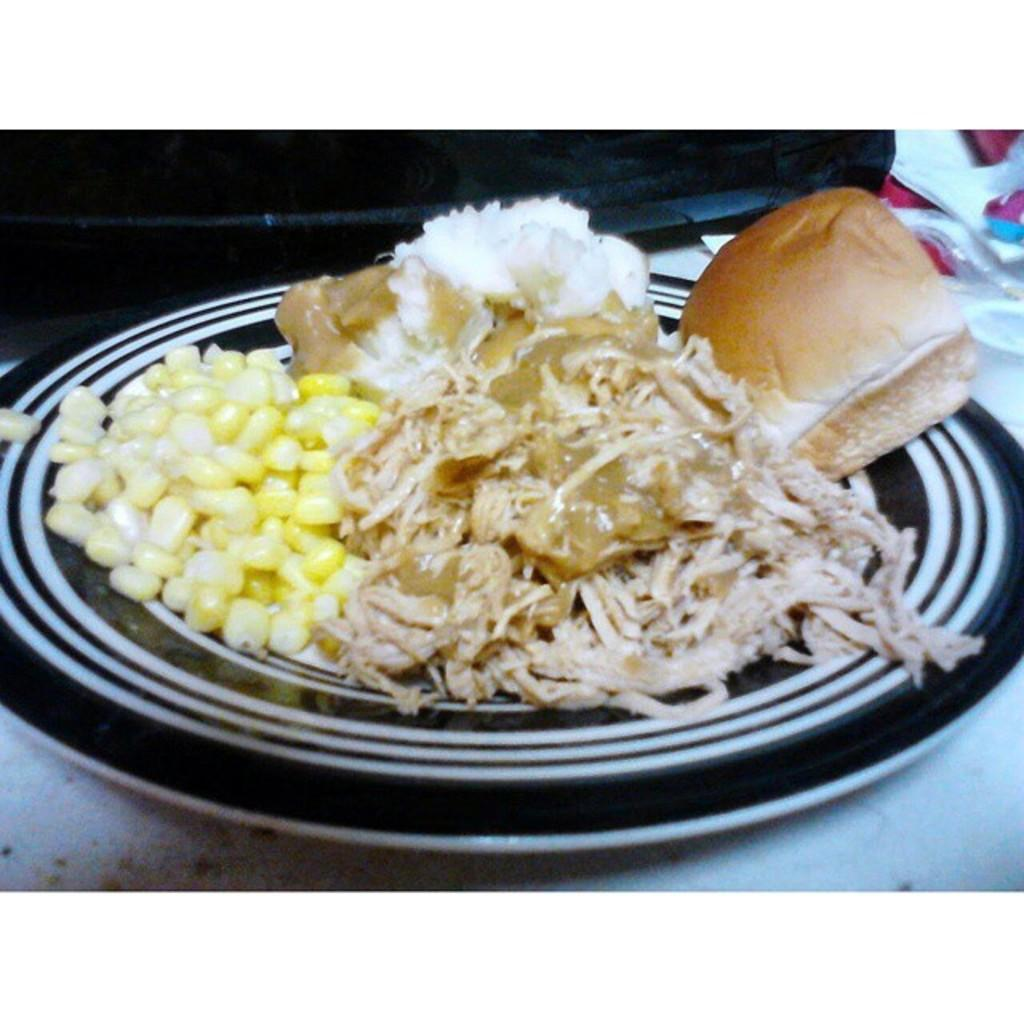What is on the plate that is visible in the image? There is food in a plate in the image. What else can be seen on the white platform in the image? There are objects on a white platform in the image. How many pigs are visible in the image? There are no pigs present in the image. What time is displayed on the clock in the image? There is no clock present in the image. 